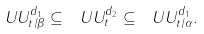Convert formula to latex. <formula><loc_0><loc_0><loc_500><loc_500>\ U U ^ { d _ { 1 } } _ { t / \beta } \subseteq \ U U ^ { d _ { 2 } } _ { t } \subseteq \ U U ^ { d _ { 1 } } _ { t / \alpha } .</formula> 